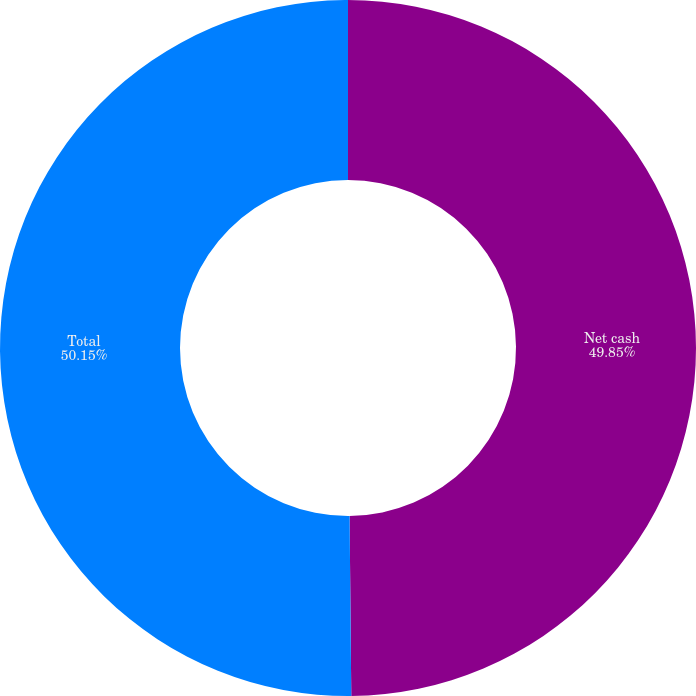Convert chart to OTSL. <chart><loc_0><loc_0><loc_500><loc_500><pie_chart><fcel>Net cash<fcel>Total<nl><fcel>49.85%<fcel>50.15%<nl></chart> 